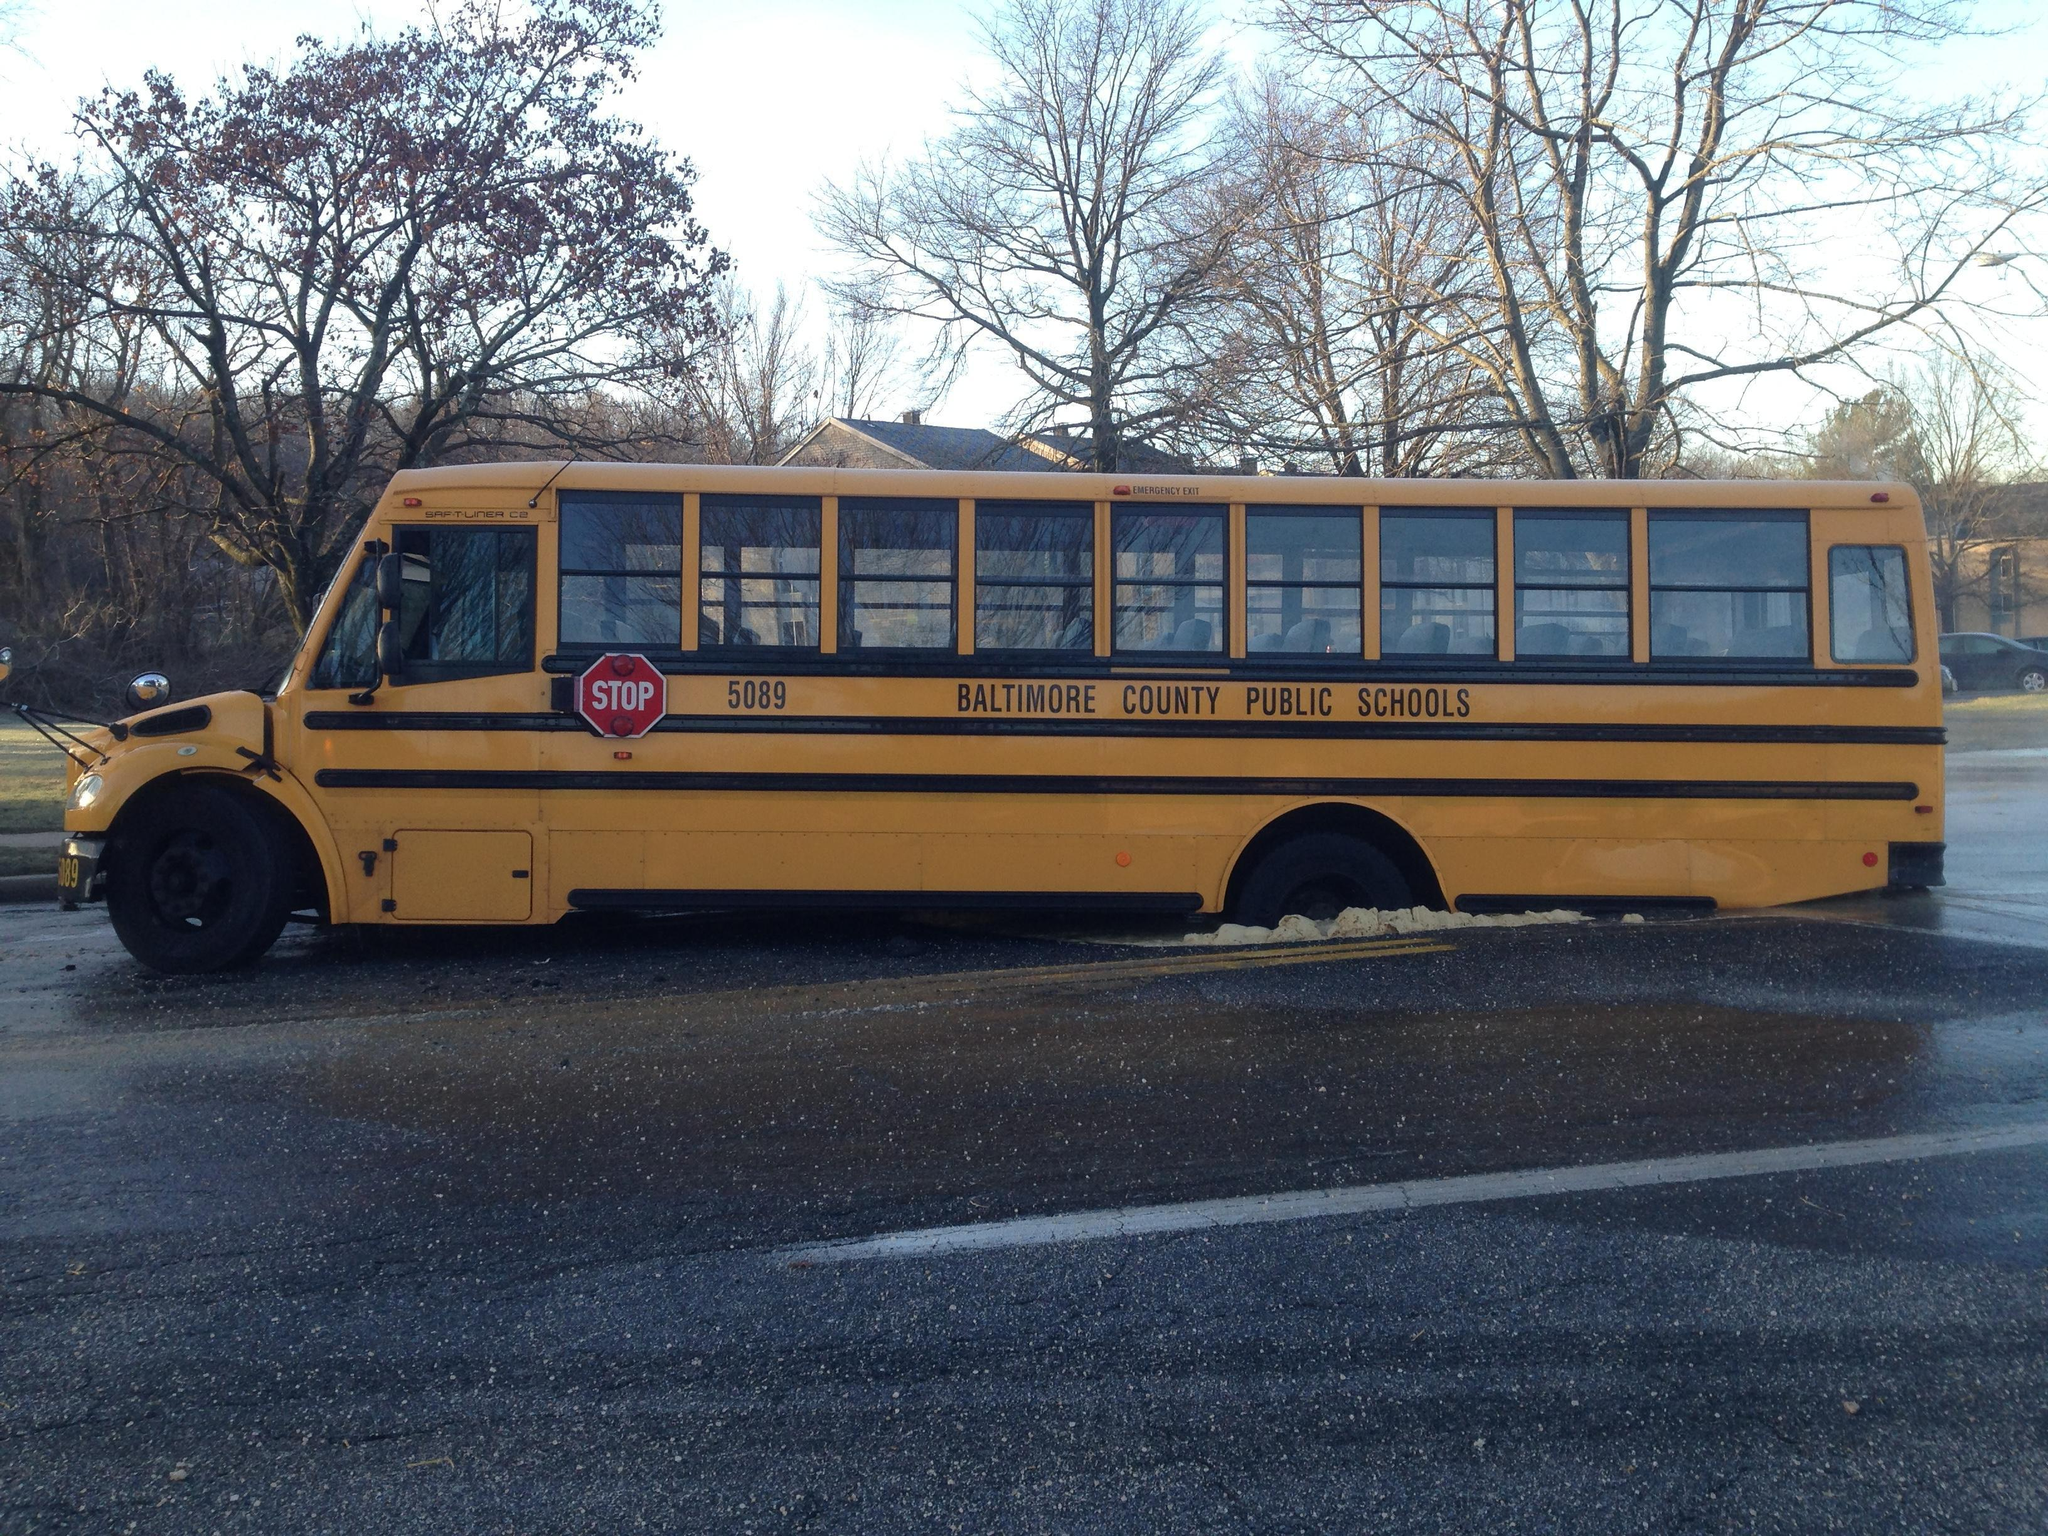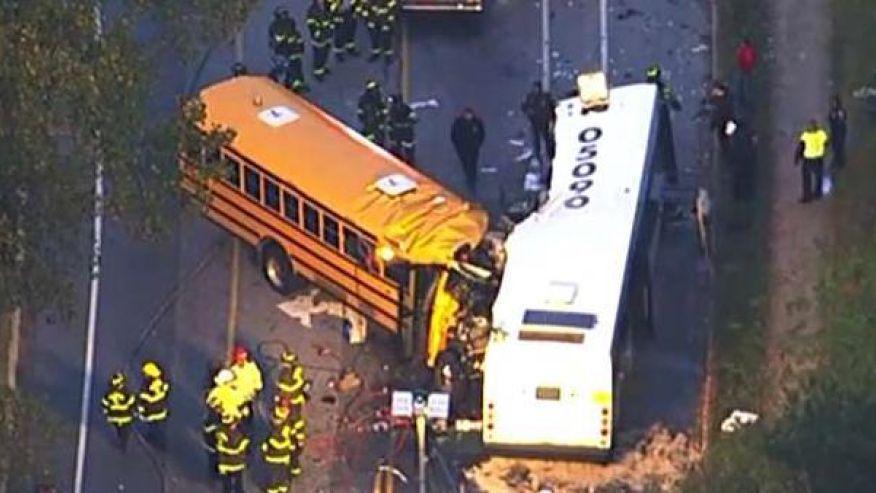The first image is the image on the left, the second image is the image on the right. For the images displayed, is the sentence "In at least one of the images, a school bus has plowed into a commuter bus." factually correct? Answer yes or no. Yes. The first image is the image on the left, the second image is the image on the right. For the images shown, is this caption "Firefighters dressed in their gear and people wearing yellow safety jackets are working at the scene of a bus accident in at least one of the images." true? Answer yes or no. Yes. 